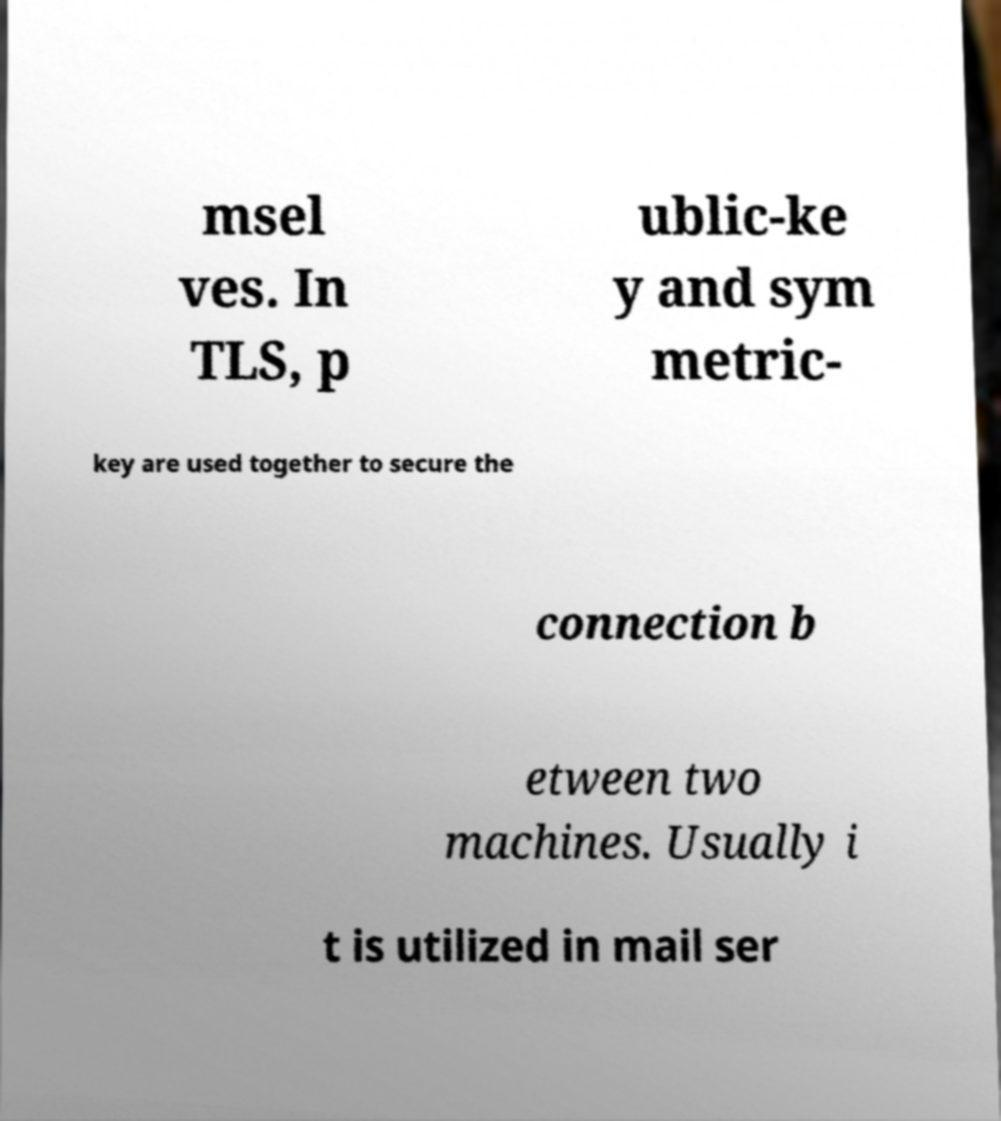Please identify and transcribe the text found in this image. msel ves. In TLS, p ublic-ke y and sym metric- key are used together to secure the connection b etween two machines. Usually i t is utilized in mail ser 